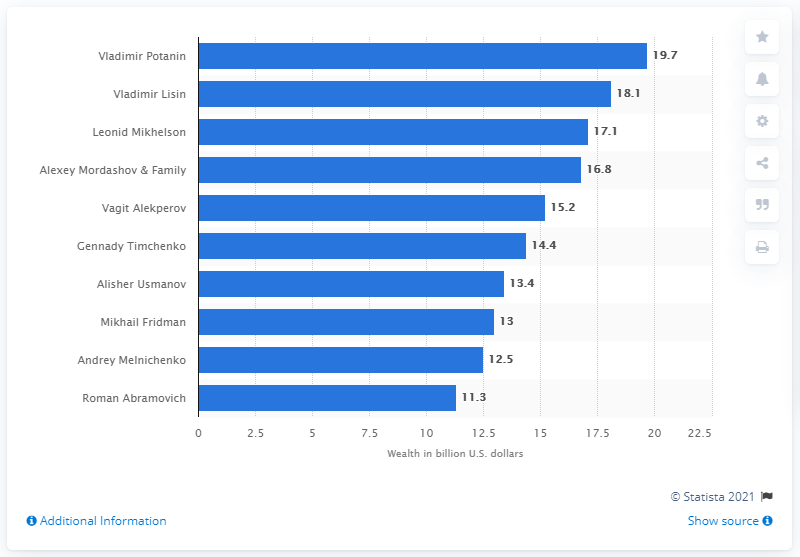Indicate a few pertinent items in this graphic. Vladimir Potanin is the richest Russian. In 2020, Vladimir Potanin's fortune was estimated to be 19.7 billion US dollars. 